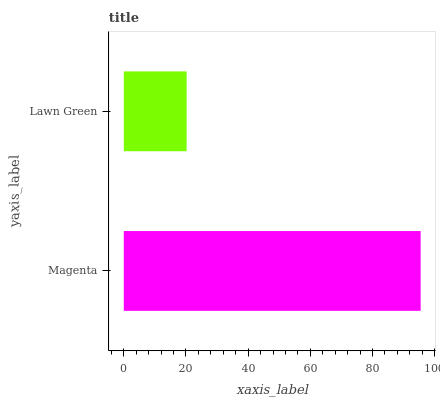Is Lawn Green the minimum?
Answer yes or no. Yes. Is Magenta the maximum?
Answer yes or no. Yes. Is Lawn Green the maximum?
Answer yes or no. No. Is Magenta greater than Lawn Green?
Answer yes or no. Yes. Is Lawn Green less than Magenta?
Answer yes or no. Yes. Is Lawn Green greater than Magenta?
Answer yes or no. No. Is Magenta less than Lawn Green?
Answer yes or no. No. Is Magenta the high median?
Answer yes or no. Yes. Is Lawn Green the low median?
Answer yes or no. Yes. Is Lawn Green the high median?
Answer yes or no. No. Is Magenta the low median?
Answer yes or no. No. 